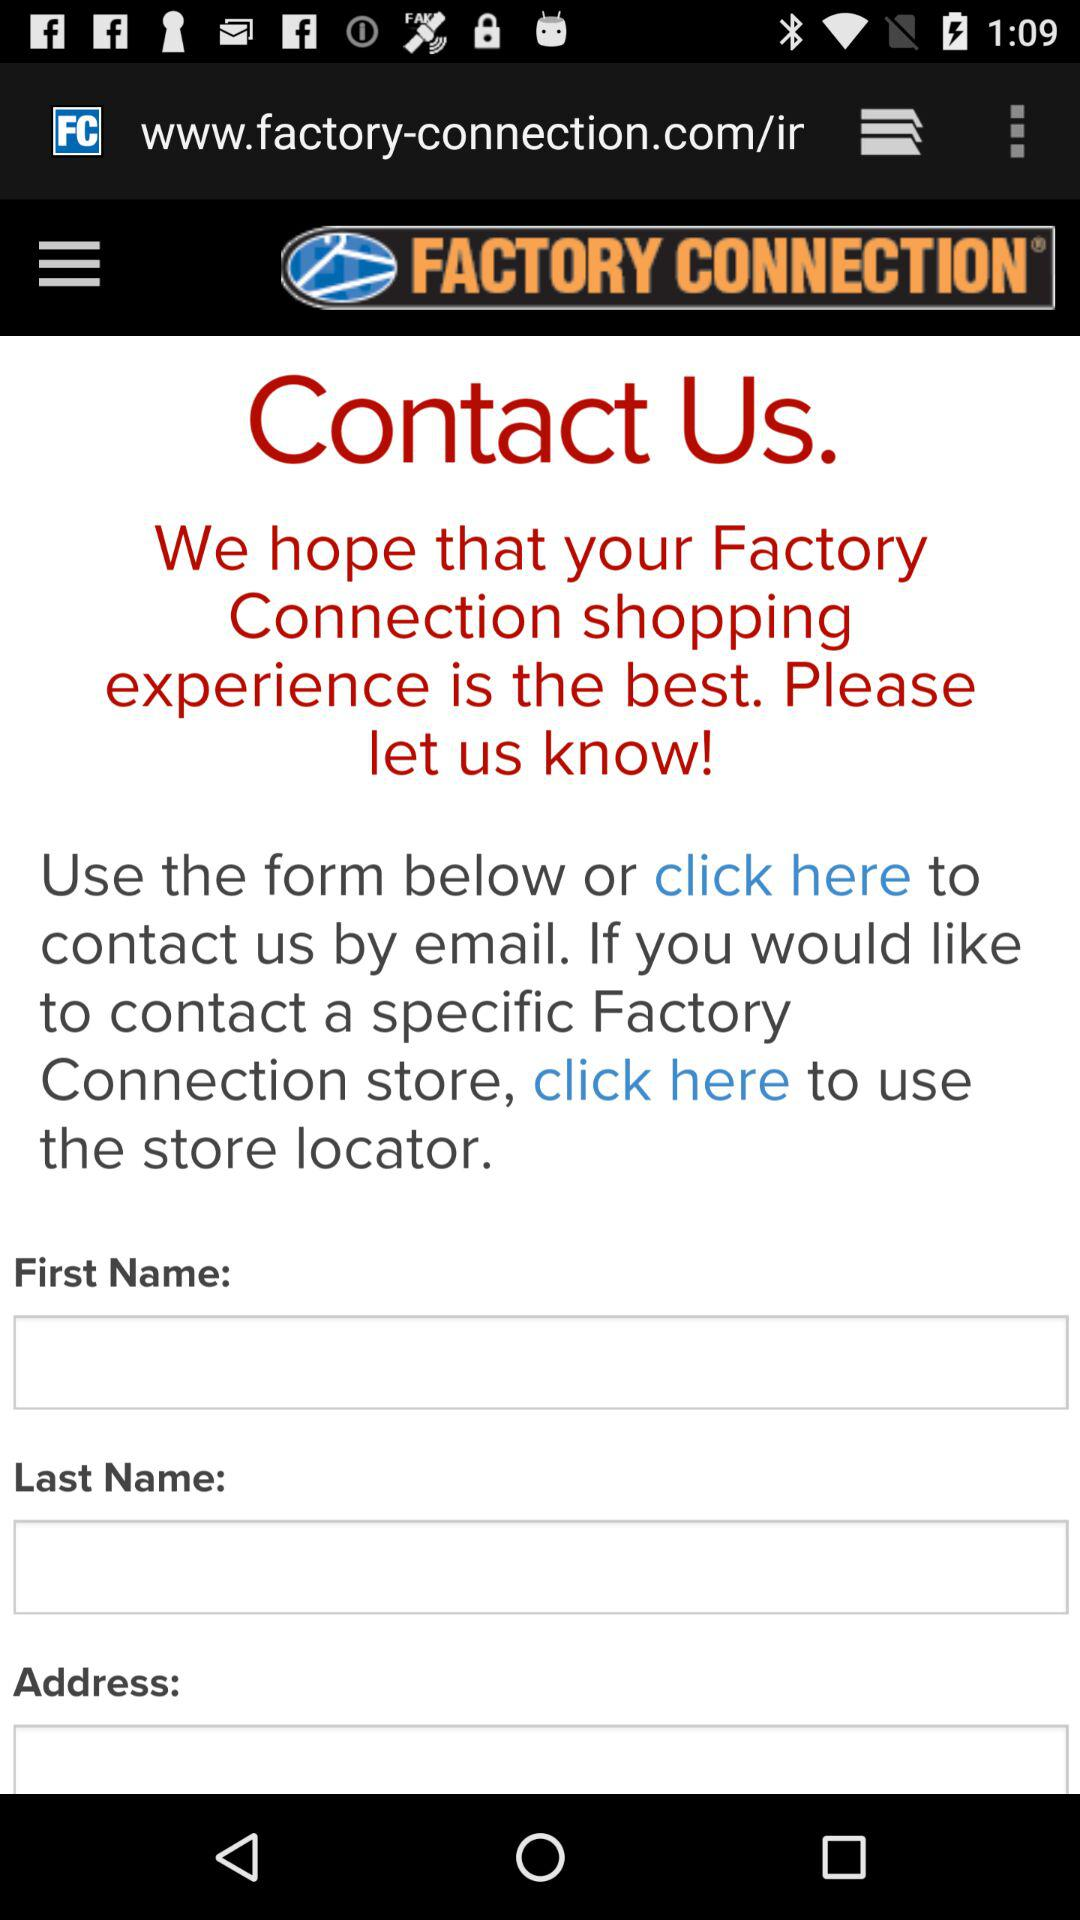What is the store name? The store name is "FACTORY CONNECTION". 